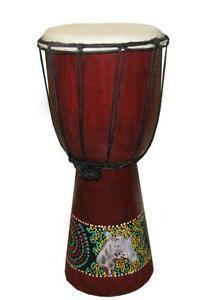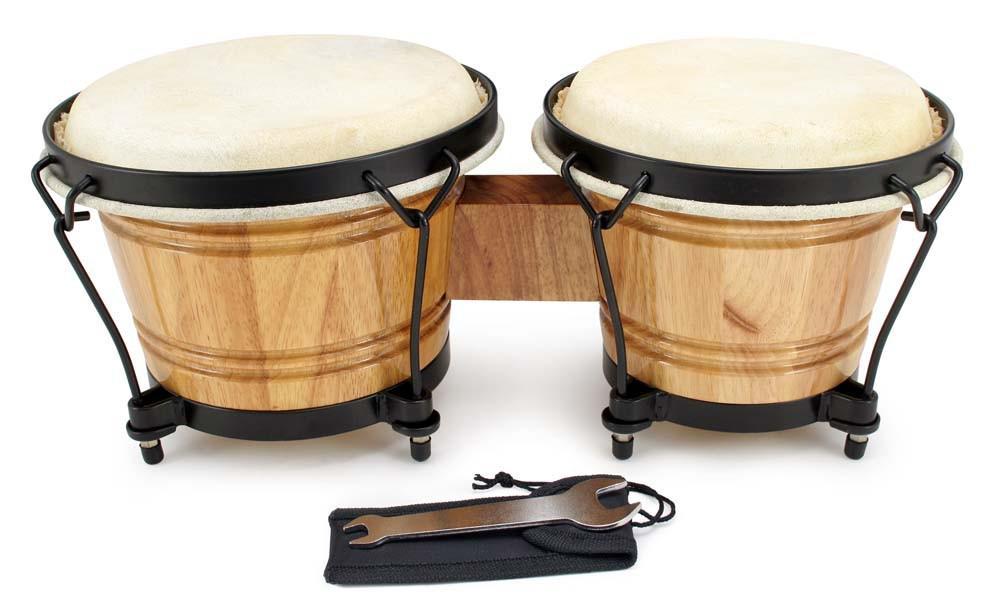The first image is the image on the left, the second image is the image on the right. Examine the images to the left and right. Is the description "There are twice as many drums in the image on the right." accurate? Answer yes or no. Yes. The first image is the image on the left, the second image is the image on the right. Examine the images to the left and right. Is the description "One image shows two basket-shaped drums connected side-by-side,and the other image shows a more slender chalice-shaped drum style, with a decorated base and rope netting around the sides." accurate? Answer yes or no. Yes. 